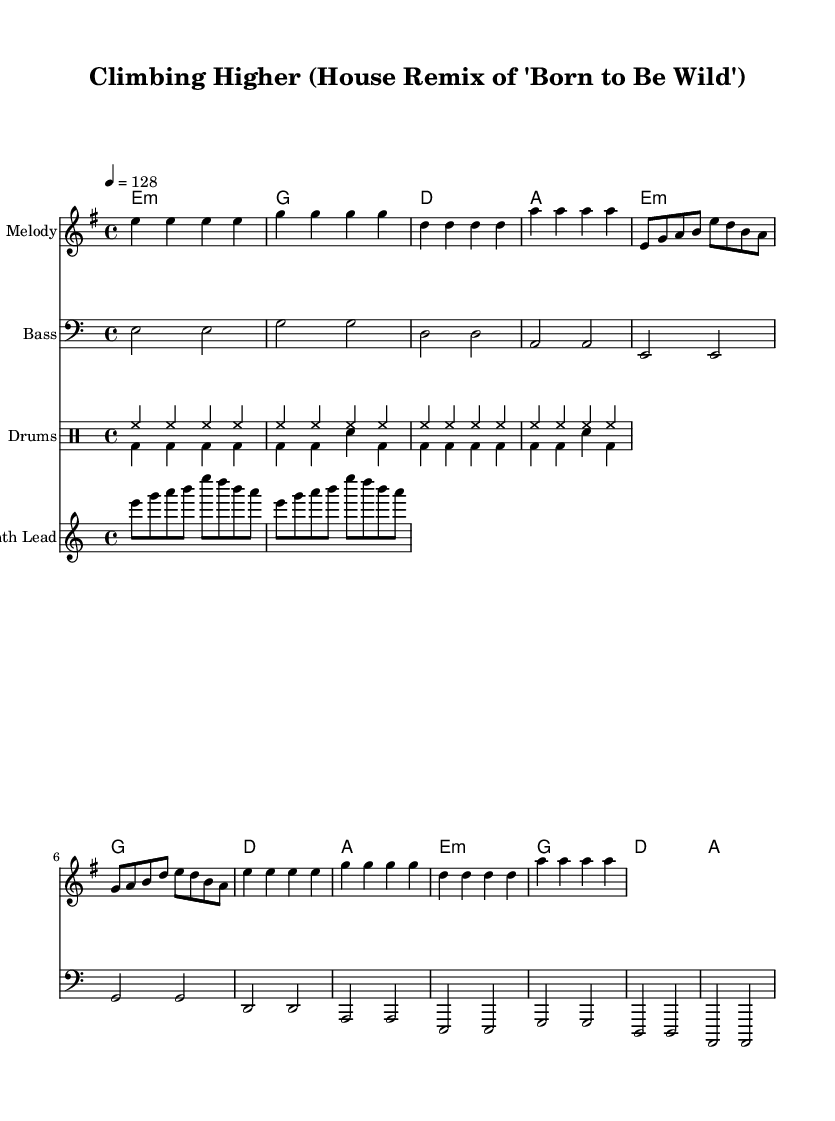What is the key signature of this music? The key signature is E minor, as indicated by the presence of one sharp, F sharp, in the key signature section of the sheet music.
Answer: E minor What is the time signature of the piece? The time signature is 4/4, which means there are four beats in each measure, and the quarter note gets one beat. This is indicated at the beginning of the music after the key signature.
Answer: 4/4 What tempo is indicated for this piece? The tempo is marked as 128 beats per minute, which is seen written at the beginning of the score next to the tempo marking.
Answer: 128 How many measures are in the intro section? The intro section contains four measures, which can be counted by looking at the measure bars at the beginning of the sheet music.
Answer: 4 Which chord appears most frequently in the harmony? The E minor chord appears most frequently, as it is shown in every measure of the harmony section throughout the piece.
Answer: E minor What is the rhythmic pattern for the drums in the drop section? The rhythmic pattern for the drums consists of four quarter notes followed by a kick drum hit followed by a snare, repeated across the measures in the drop section, indicating a driving beat consistent with house music.
Answer: Four quarter notes, snare What type of synthesizer lead is used in this remix? The synthesizer lead is a melodic line that provides a catchy, high-energy motif, typical of house remixes, as seen in the melody staff created for the synth lead.
Answer: Melodic 